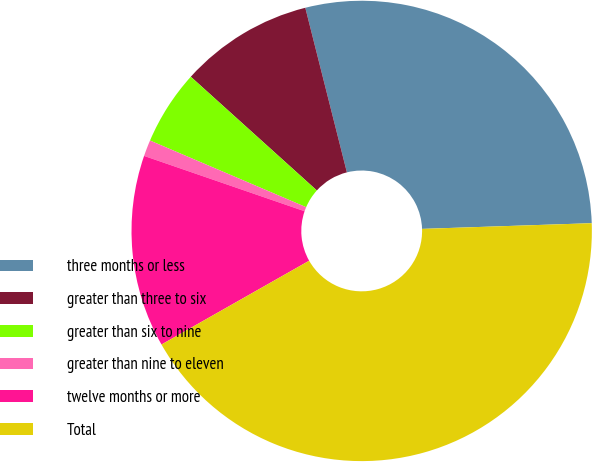Convert chart. <chart><loc_0><loc_0><loc_500><loc_500><pie_chart><fcel>three months or less<fcel>greater than three to six<fcel>greater than six to nine<fcel>greater than nine to eleven<fcel>twelve months or more<fcel>Total<nl><fcel>28.41%<fcel>9.38%<fcel>5.26%<fcel>1.14%<fcel>13.5%<fcel>42.33%<nl></chart> 